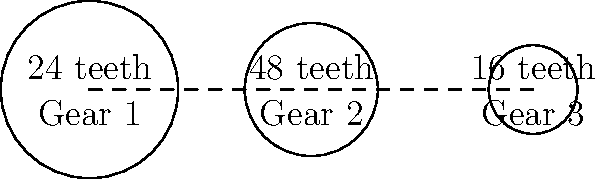In a simple gear train system used in a local textile factory in Burundi, there are three gears connected in series as shown in the diagram. Gear 1 has 24 teeth, Gear 2 has 48 teeth, and Gear 3 has 16 teeth. If Gear 1 rotates at 120 rpm (revolutions per minute), what is the speed of Gear 3 in rpm? To solve this problem, we'll follow these steps:

1. Understand the concept of gear ratio:
   The gear ratio between two meshing gears is the ratio of their number of teeth, which is inversely proportional to their angular velocities.

2. Calculate the gear ratio between Gear 1 and Gear 2:
   $$ \text{Ratio}_{1,2} = \frac{\text{Teeth of Gear 2}}{\text{Teeth of Gear 1}} = \frac{48}{24} = 2 $$

3. Calculate the speed of Gear 2:
   $$ \text{Speed of Gear 2} = \frac{\text{Speed of Gear 1}}{\text{Ratio}_{1,2}} = \frac{120 \text{ rpm}}{2} = 60 \text{ rpm} $$

4. Calculate the gear ratio between Gear 2 and Gear 3:
   $$ \text{Ratio}_{2,3} = \frac{\text{Teeth of Gear 2}}{\text{Teeth of Gear 3}} = \frac{48}{16} = 3 $$

5. Calculate the speed of Gear 3:
   $$ \text{Speed of Gear 3} = \text{Speed of Gear 2} \times \text{Ratio}_{2,3} = 60 \text{ rpm} \times 3 = 180 \text{ rpm} $$

Therefore, Gear 3 rotates at 180 rpm.
Answer: 180 rpm 